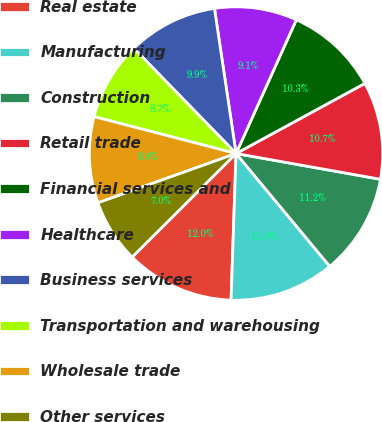Convert chart to OTSL. <chart><loc_0><loc_0><loc_500><loc_500><pie_chart><fcel>Real estate<fcel>Manufacturing<fcel>Construction<fcel>Retail trade<fcel>Financial services and<fcel>Healthcare<fcel>Business services<fcel>Transportation and warehousing<fcel>Wholesale trade<fcel>Other services<nl><fcel>11.98%<fcel>11.57%<fcel>11.16%<fcel>10.74%<fcel>10.33%<fcel>9.09%<fcel>9.92%<fcel>8.68%<fcel>9.5%<fcel>7.02%<nl></chart> 